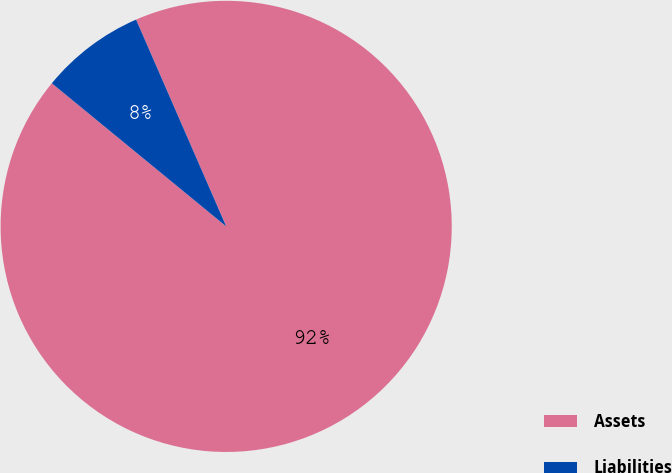Convert chart to OTSL. <chart><loc_0><loc_0><loc_500><loc_500><pie_chart><fcel>Assets<fcel>Liabilities<nl><fcel>92.48%<fcel>7.52%<nl></chart> 